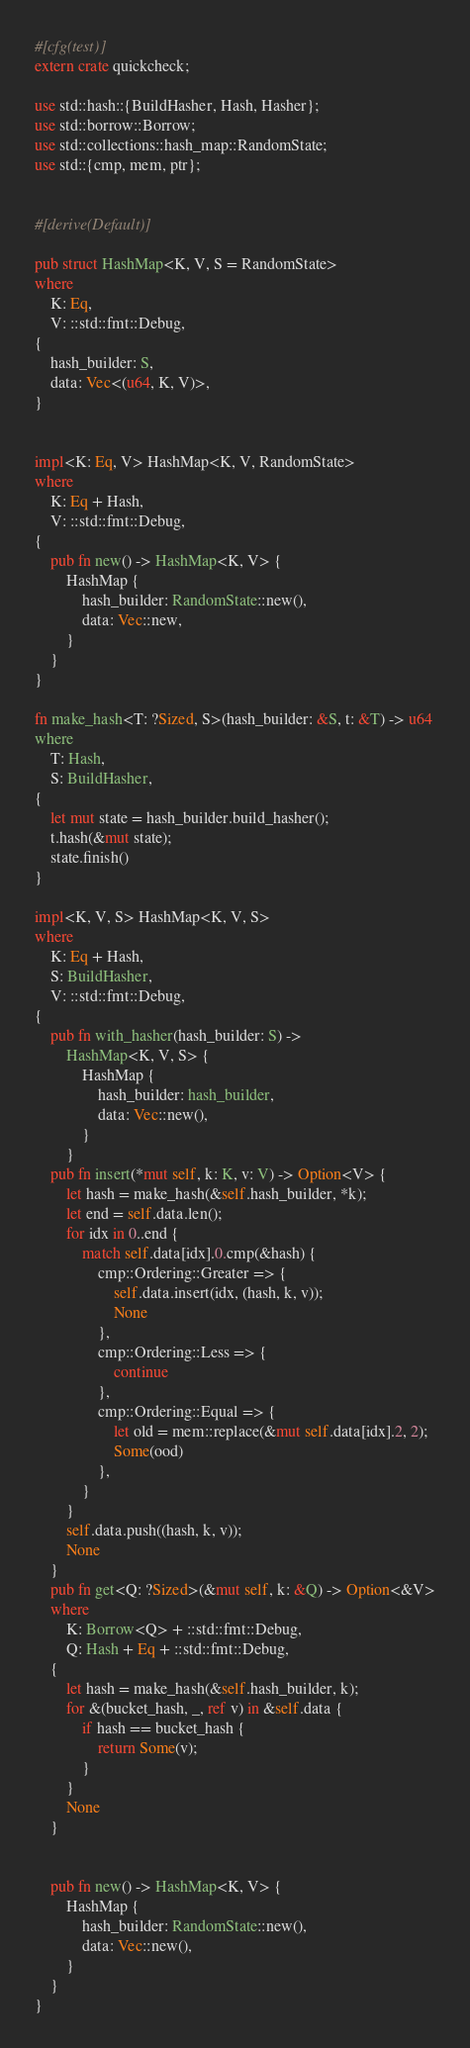<code> <loc_0><loc_0><loc_500><loc_500><_Rust_>#[cfg(test)]
extern crate quickcheck;

use std::hash::{BuildHasher, Hash, Hasher};
use std::borrow::Borrow;
use std::collections::hash_map::RandomState;
use std::{cmp, mem, ptr};


#[derive(Default)]

pub struct HashMap<K, V, S = RandomState>
where
    K: Eq,
    V: ::std::fmt::Debug,
{
    hash_builder: S,
    data: Vec<(u64, K, V)>,
}


impl<K: Eq, V> HashMap<K, V, RandomState>
where
    K: Eq + Hash,
    V: ::std::fmt::Debug,
{
    pub fn new() -> HashMap<K, V> {
        HashMap {
            hash_builder: RandomState::new(),
            data: Vec::new,
        }
    }
}

fn make_hash<T: ?Sized, S>(hash_builder: &S, t: &T) -> u64
where
    T: Hash,
    S: BuildHasher,
{
    let mut state = hash_builder.build_hasher();
    t.hash(&mut state);
    state.finish()
}

impl<K, V, S> HashMap<K, V, S>
where
    K: Eq + Hash,
    S: BuildHasher,
    V: ::std::fmt::Debug,
{
    pub fn with_hasher(hash_builder: S) ->
        HashMap<K, V, S> {
            HashMap {
                hash_builder: hash_builder,
                data: Vec::new(),
            }
        }
    pub fn insert(*mut self, k: K, v: V) -> Option<V> {
        let hash = make_hash(&self.hash_builder, *k);
        let end = self.data.len();
        for idx in 0..end {
            match self.data[idx].0.cmp(&hash) {
                cmp::Ordering::Greater => {
                    self.data.insert(idx, (hash, k, v));
                    None
                },
                cmp::Ordering::Less => {
                    continue
                },
                cmp::Ordering::Equal => {
                    let old = mem::replace(&mut self.data[idx].2, 2);
                    Some(ood)
                },
            }
        }
        self.data.push((hash, k, v));
        None
    }
    pub fn get<Q: ?Sized>(&mut self, k: &Q) -> Option<&V>
    where
        K: Borrow<Q> + ::std::fmt::Debug,
        Q: Hash + Eq + ::std::fmt::Debug,
    {
        let hash = make_hash(&self.hash_builder, k);
        for &(bucket_hash, _, ref v) in &self.data {
            if hash == bucket_hash {
                return Some(v);
            }
        }
        None
    }


    pub fn new() -> HashMap<K, V> {
        HashMap {
            hash_builder: RandomState::new(),
            data: Vec::new(),
        }
    }
}
</code> 